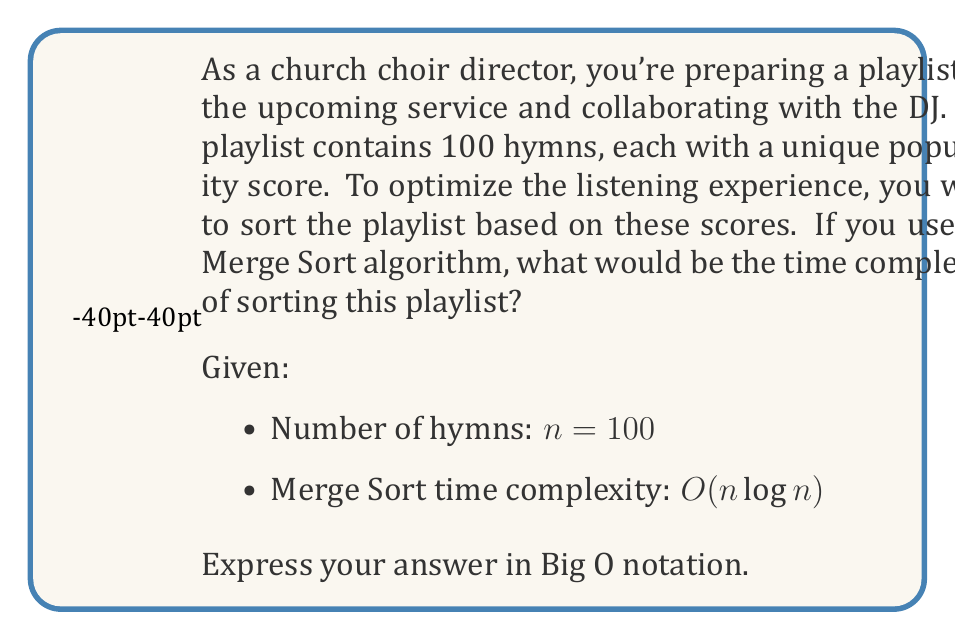Can you solve this math problem? Let's break this down step-by-step:

1) The Merge Sort algorithm has a time complexity of $O(n \log n)$ for all cases (best, average, and worst).

2) In this scenario, we have $n = 100$ hymns.

3) To find the time complexity, we simply substitute $n$ with 100 in the general formula:

   $O(n \log n)$ becomes $O(100 \log 100)$

4) However, in Big O notation, we're interested in the growth rate as $n$ approaches infinity, not the specific value of $n$. Constants (like 100) are ignored because they don't affect the overall growth rate.

5) Therefore, even though we have a specific number of hymns, the time complexity remains $O(n \log n)$.

This means that as the number of hymns in your playlist increases, the time taken to sort them will grow at a rate of $n \log n$, which is more efficient than quadratic time $O(n^2)$ but less efficient than linear time $O(n)$.
Answer: $O(n \log n)$ 